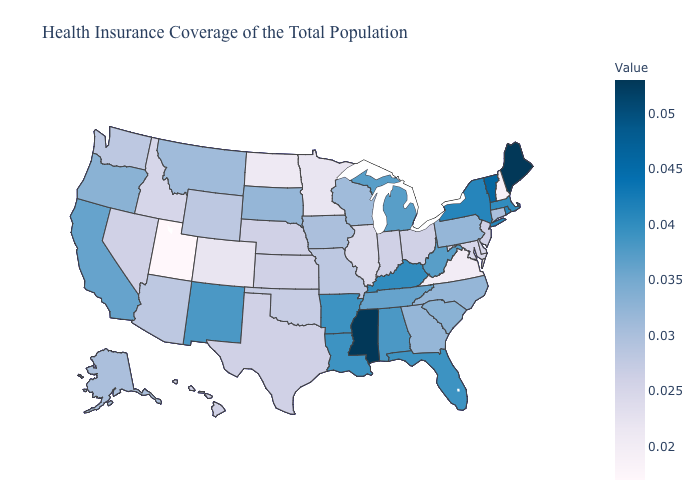Does Wyoming have the lowest value in the USA?
Answer briefly. No. Among the states that border Nevada , which have the lowest value?
Write a very short answer. Utah. Among the states that border Montana , does North Dakota have the highest value?
Concise answer only. No. Among the states that border Washington , which have the lowest value?
Quick response, please. Idaho. Does New Hampshire have the lowest value in the Northeast?
Keep it brief. Yes. Does North Dakota have the lowest value in the MidWest?
Concise answer only. Yes. 